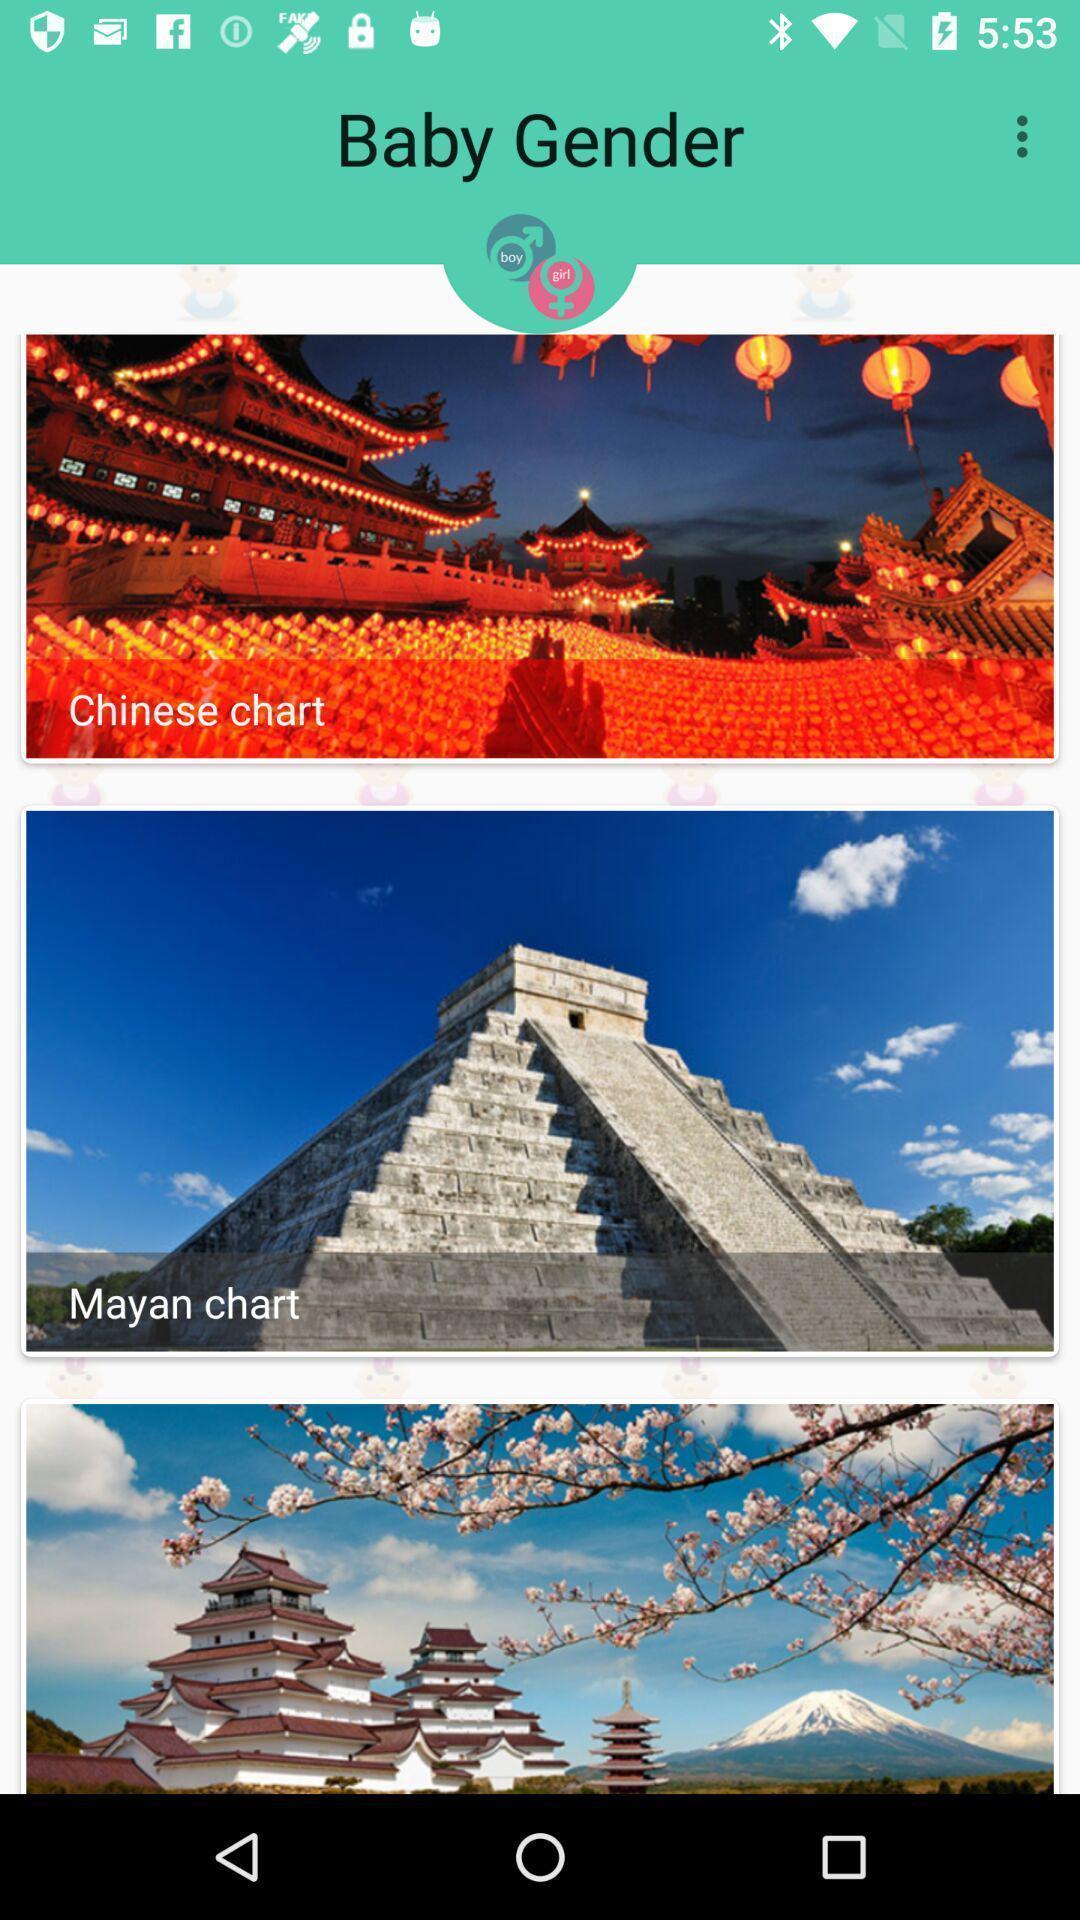Give me a summary of this screen capture. Screen page displaying multiple images. 